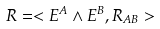<formula> <loc_0><loc_0><loc_500><loc_500>R = < E ^ { A } \wedge E ^ { B } , R _ { A B } ></formula> 